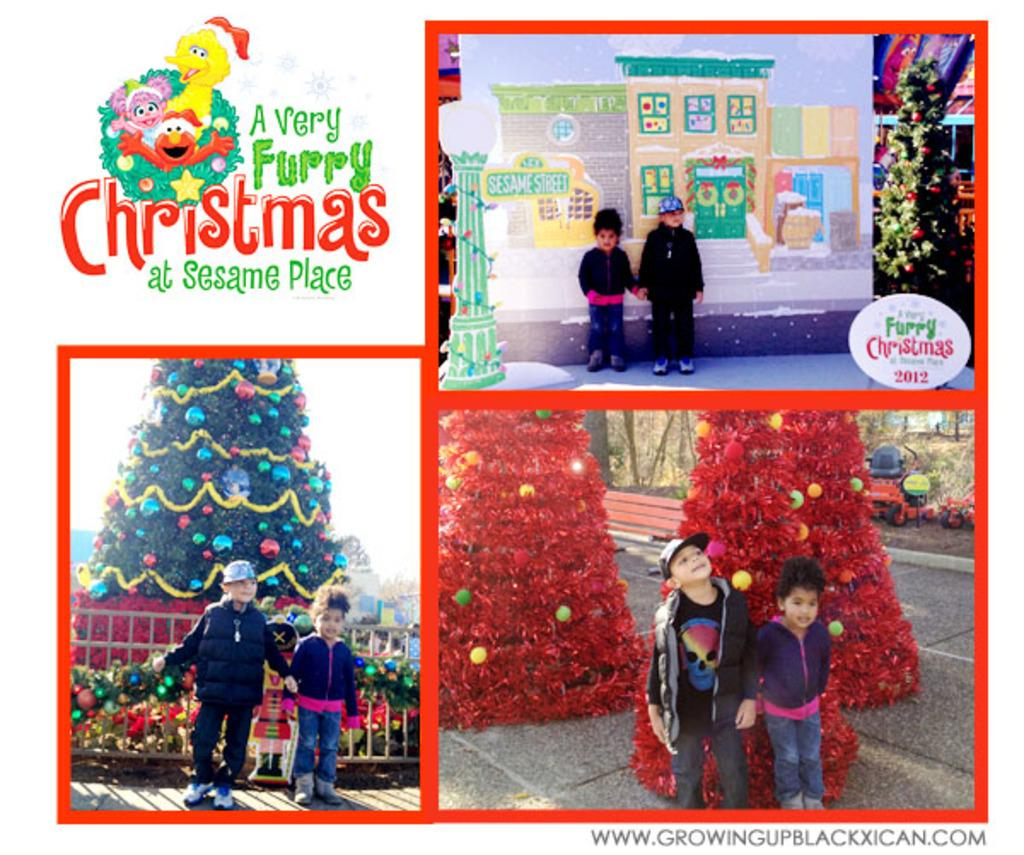What type of artwork is depicted in the image? The image is a collage. How many children are featured in the collage? There are two children in the collage. What are the children doing in the collage? The children are taking pictures in different places. Are there any words present in the collage? Yes, there are words written in the collage. What type of glove is the child wearing in the image? There is no glove visible in the image; the children are taking pictures. Can you describe the body language of the children in the image? The provided facts do not mention the body language of the children, only that they are taking pictures in different places. 